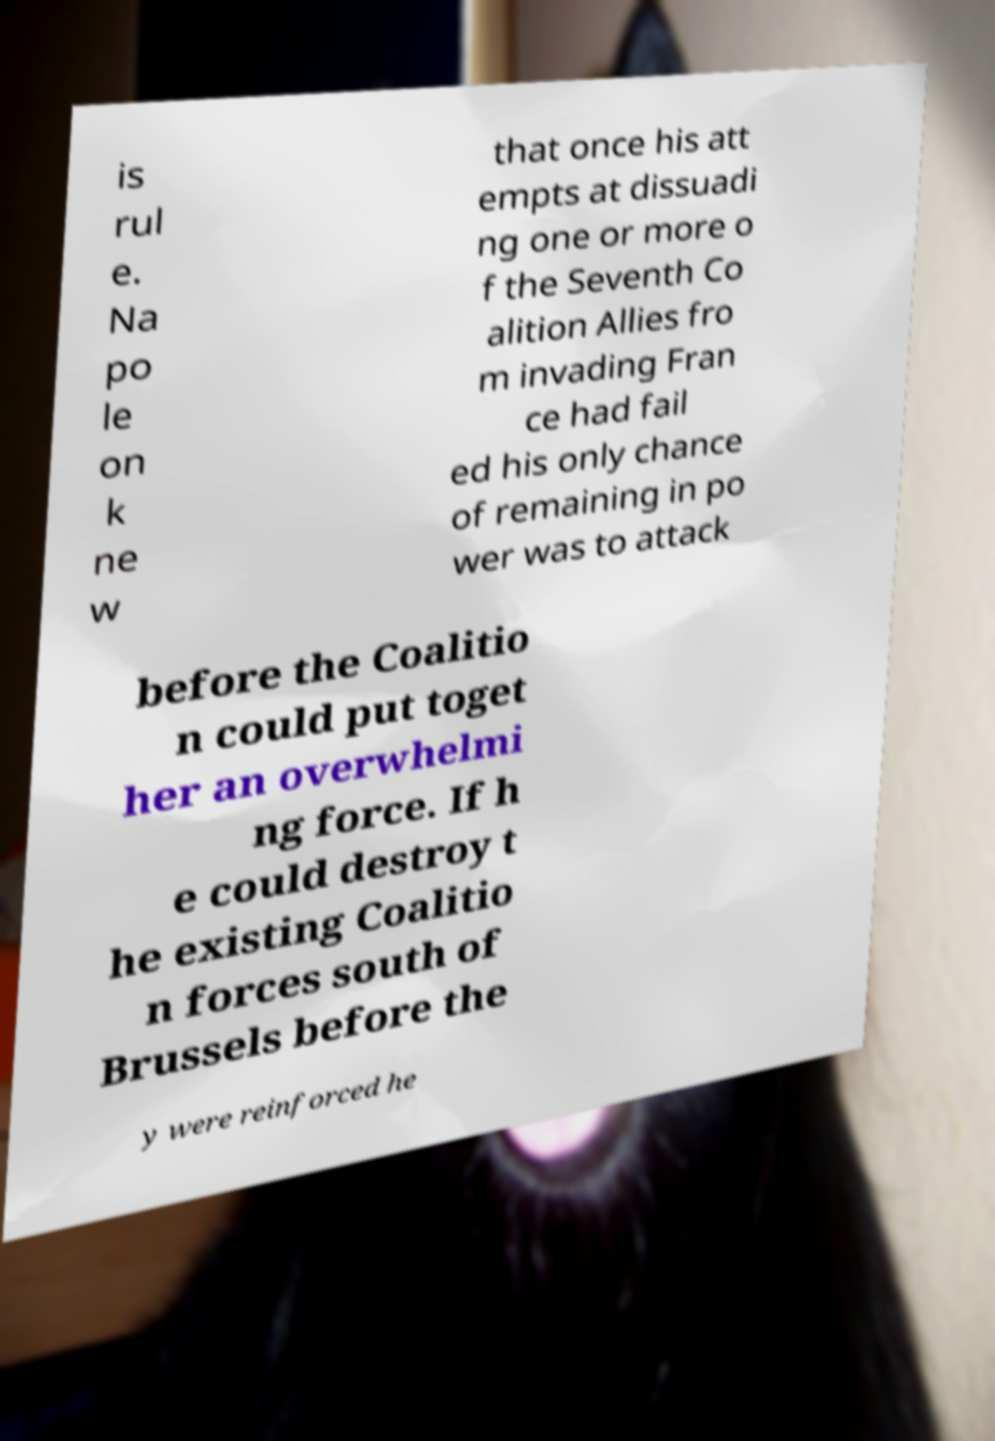Could you assist in decoding the text presented in this image and type it out clearly? is rul e. Na po le on k ne w that once his att empts at dissuadi ng one or more o f the Seventh Co alition Allies fro m invading Fran ce had fail ed his only chance of remaining in po wer was to attack before the Coalitio n could put toget her an overwhelmi ng force. If h e could destroy t he existing Coalitio n forces south of Brussels before the y were reinforced he 